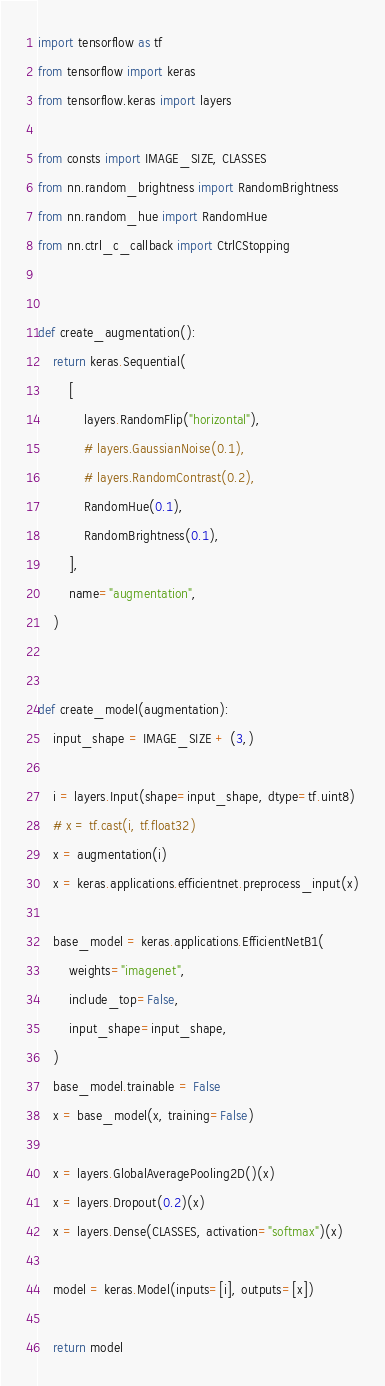Convert code to text. <code><loc_0><loc_0><loc_500><loc_500><_Python_>import tensorflow as tf
from tensorflow import keras
from tensorflow.keras import layers

from consts import IMAGE_SIZE, CLASSES
from nn.random_brightness import RandomBrightness
from nn.random_hue import RandomHue
from nn.ctrl_c_callback import CtrlCStopping


def create_augmentation():
    return keras.Sequential(
        [
            layers.RandomFlip("horizontal"),
            # layers.GaussianNoise(0.1),
            # layers.RandomContrast(0.2),
            RandomHue(0.1),
            RandomBrightness(0.1),
        ],
        name="augmentation",
    )


def create_model(augmentation):
    input_shape = IMAGE_SIZE + (3,)

    i = layers.Input(shape=input_shape, dtype=tf.uint8)
    # x = tf.cast(i, tf.float32)
    x = augmentation(i)
    x = keras.applications.efficientnet.preprocess_input(x)

    base_model = keras.applications.EfficientNetB1(
        weights="imagenet",
        include_top=False,
        input_shape=input_shape,
    )
    base_model.trainable = False
    x = base_model(x, training=False)

    x = layers.GlobalAveragePooling2D()(x)
    x = layers.Dropout(0.2)(x)
    x = layers.Dense(CLASSES, activation="softmax")(x)

    model = keras.Model(inputs=[i], outputs=[x])

    return model
</code> 